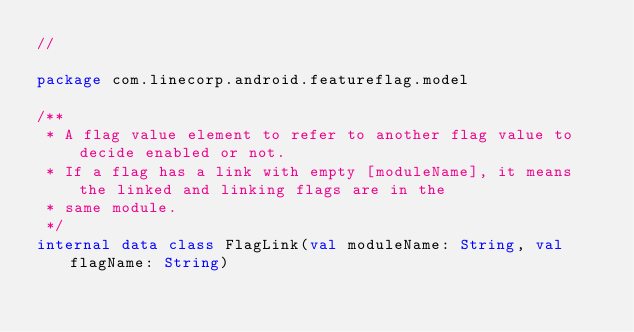Convert code to text. <code><loc_0><loc_0><loc_500><loc_500><_Kotlin_>//

package com.linecorp.android.featureflag.model

/**
 * A flag value element to refer to another flag value to decide enabled or not.
 * If a flag has a link with empty [moduleName], it means the linked and linking flags are in the
 * same module.
 */
internal data class FlagLink(val moduleName: String, val flagName: String)
</code> 